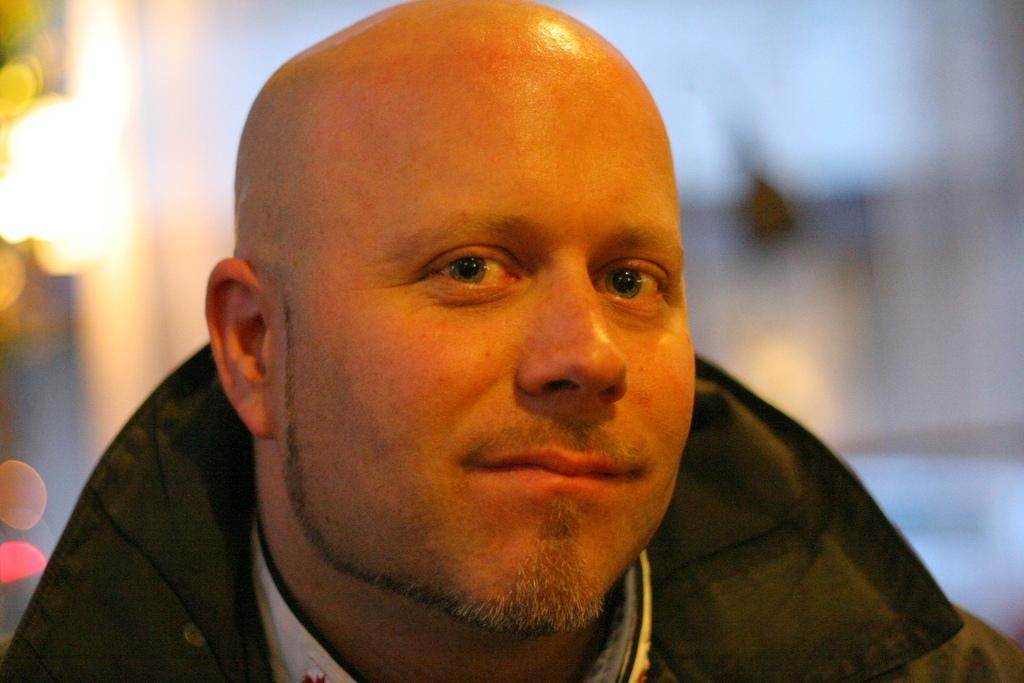Who is the main subject in the image? There is a man in the image. What can be observed about the background of the image? The background of the image is blurred. What type of clothing is the man wearing? The man is wearing a jacket. What direction is the man facing in the image? The provided facts do not mention the direction the man is facing, so we cannot determine that from the image. 